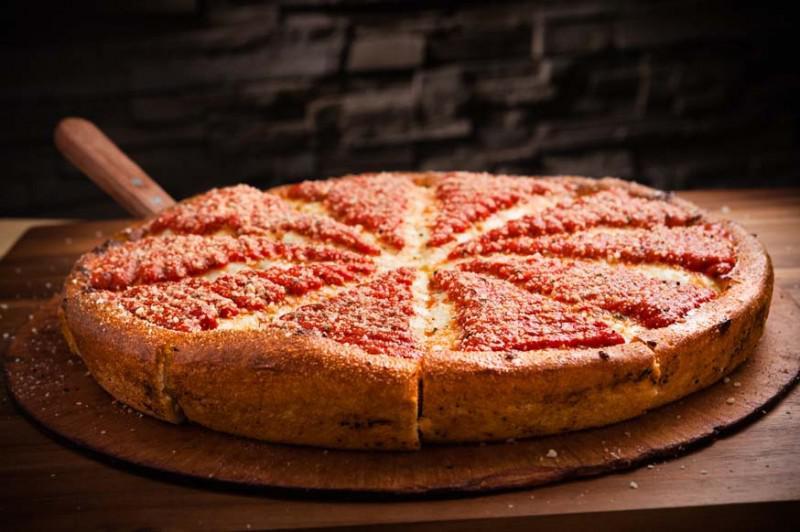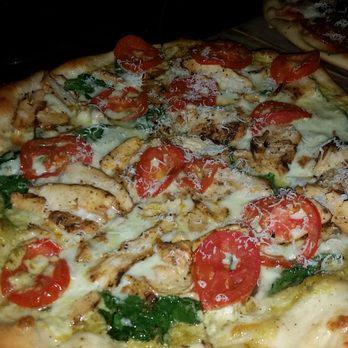The first image is the image on the left, the second image is the image on the right. Assess this claim about the two images: "The pizza in the image on the left is sitting in a cardboard box.". Correct or not? Answer yes or no. No. The first image is the image on the left, the second image is the image on the right. Considering the images on both sides, is "There are two pizzas with one still in a cardboard box." valid? Answer yes or no. No. 